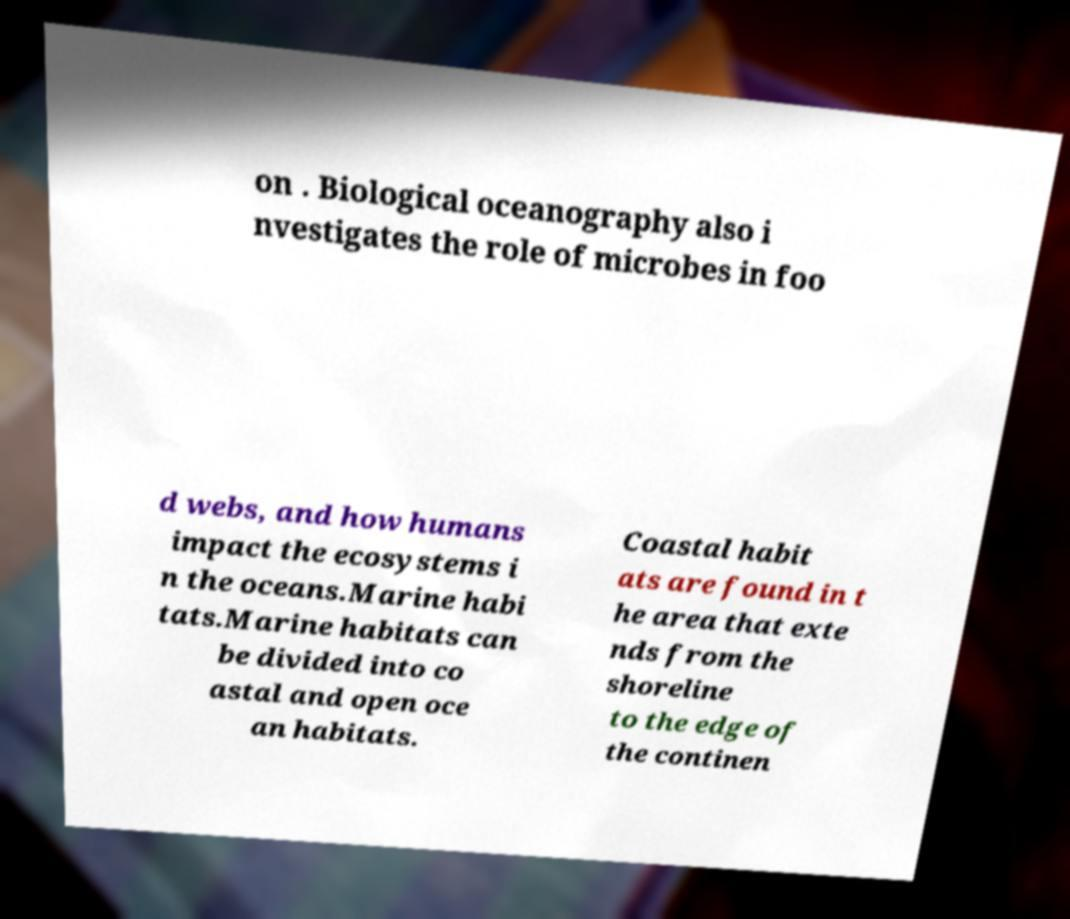Please read and relay the text visible in this image. What does it say? on . Biological oceanography also i nvestigates the role of microbes in foo d webs, and how humans impact the ecosystems i n the oceans.Marine habi tats.Marine habitats can be divided into co astal and open oce an habitats. Coastal habit ats are found in t he area that exte nds from the shoreline to the edge of the continen 